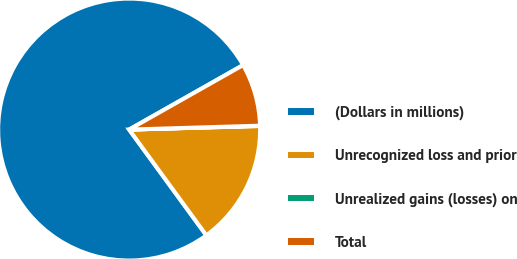<chart> <loc_0><loc_0><loc_500><loc_500><pie_chart><fcel>(Dollars in millions)<fcel>Unrecognized loss and prior<fcel>Unrealized gains (losses) on<fcel>Total<nl><fcel>76.84%<fcel>15.4%<fcel>0.04%<fcel>7.72%<nl></chart> 